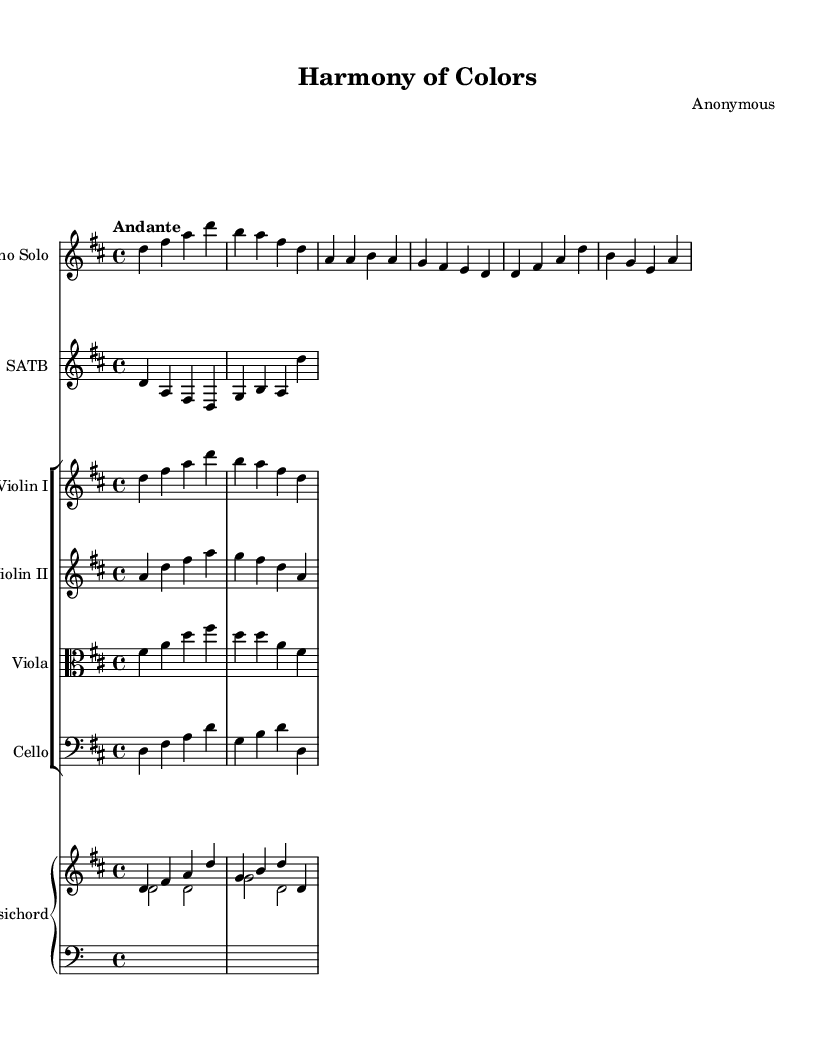What is the key signature of this music? The key signature is D major, which has two sharps (F# and C#). This can be identified at the beginning of the staff notation, where the sharps are indicated.
Answer: D major What is the time signature of this music? The time signature is 4/4, denoted at the beginning of the score. This means there are four beats in a measure and the quarter note gets one beat.
Answer: 4/4 What is the tempo marking of this piece? The tempo marking is "Andante," which indicates a moderate pace of music. This term appears at the beginning of the score under the global directive.
Answer: Andante How many instruments are present in this composition? There are six distinct parts listed: Soprano Solo, SATB Choir, Violin I, Violin II, Viola, Cello, and Harpsichord. Each part appears in its own designated staff or group.
Answer: Six What is the primary musical form used in this piece? The piece primarily presents an oratorio structure, typically featuring recitative and aria sections, which can be inferred from the labeling in the soprano part indicating distinct musical sections.
Answer: Oratorio What is the role of the Harpsichord in this score? The Harpsichord serves as a continuo instrument providing harmonic support. It has a right and left hand part, creating a balanced texture that is characteristic of Baroque music.
Answer: Continuo How many measures are in the provided excerpt for the soprano solo? The provided excerpt for the soprano solo contains four measures, as counted from the beginning of the line until the end of the notation.
Answer: Four 